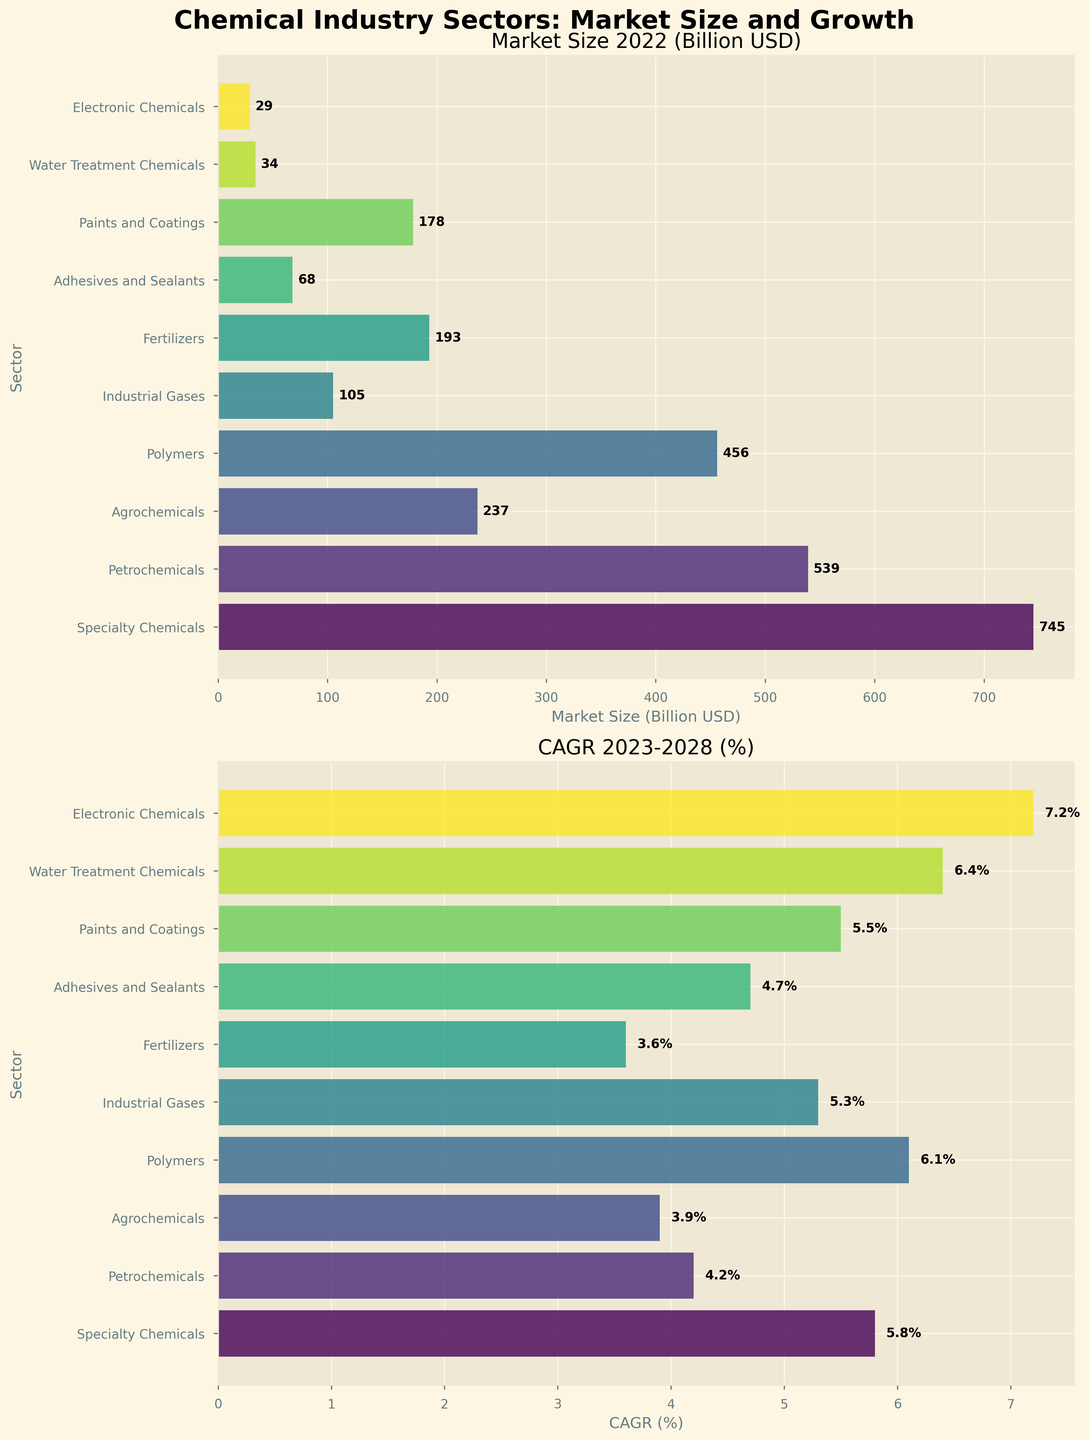What is the market size of the largest sector in 2022? Observing the upper subplot, the Specialty Chemicals sector has the highest bar, indicating the largest market size. The label on the bar reads 745 billion USD.
Answer: 745 billion USD Which sector has the highest CAGR from 2023-2028? In the lower subplot, the Electronic Chemicals sector has the highest bar, indicating the highest CAGR. The label on the bar reads 7.2%.
Answer: Electronic Chemicals How many sectors have a CAGR greater than 5%? Counting the bars above the 5% mark on the lower subplot reveals these sectors: Specialty Chemicals, Polymers, Industrial Gases, Paints and Coatings, Water Treatment Chemicals, and Electronic Chemicals. This totals to six sectors.
Answer: 6 What is the combined market size of Petrochemicals and Agrochemicals in 2022? According to the upper subplot, the market sizes are 539 billion USD for Petrochemicals and 237 billion USD for Agrochemicals. Adding these together: 539 + 237 = 776 billion USD.
Answer: 776 billion USD Which sector has a higher market size in 2022, Polymers or Fertilizers? By comparing the heights of the bars in the upper subplot, the Polymers sector has a larger bar (456 billion USD) than the Fertilizers sector (193 billion USD).
Answer: Polymers What is the average CAGR of sectors with a market size under 200 billion USD in 2022? The relevant sectors and their CAGRs are: Industrial Gases (5.3%), Fertilizers (3.6%), Adhesives and Sealants (4.7%), Paints and Coatings (5.5%), Water Treatment Chemicals (6.4%), and Electronic Chemicals (7.2%). Summing these: 5.3 + 3.6 + 4.7 + 5.5 + 6.4 + 7.2 = 32.7. Dividing by the number of sectors (6): 32.7 / 6 = 5.45%.
Answer: 5.45% What is the total market size of all sectors in 2022? Adding up the market sizes from the upper subplot: 745 + 539 + 237 + 456 + 105 + 193 + 68 + 178 + 34 + 29 = 2584 billion USD.
Answer: 2584 billion USD Between Agrochemicals and Adhesives and Sealants, which sector has a higher CAGR from 2023-2028? Comparing the bars in the lower subplot, Agrochemicals has a CAGR of 3.9%, and Adhesives and Sealants has a CAGR of 4.7%. Therefore, Adhesives and Sealants has a higher CAGR.
Answer: Adhesives and Sealants Which sector has the smallest market size in 2022? The shortest bar in the upper subplot represents the sector with the smallest market size, which is the Electronic Chemicals sector with 29 billion USD.
Answer: Electronic Chemicals 